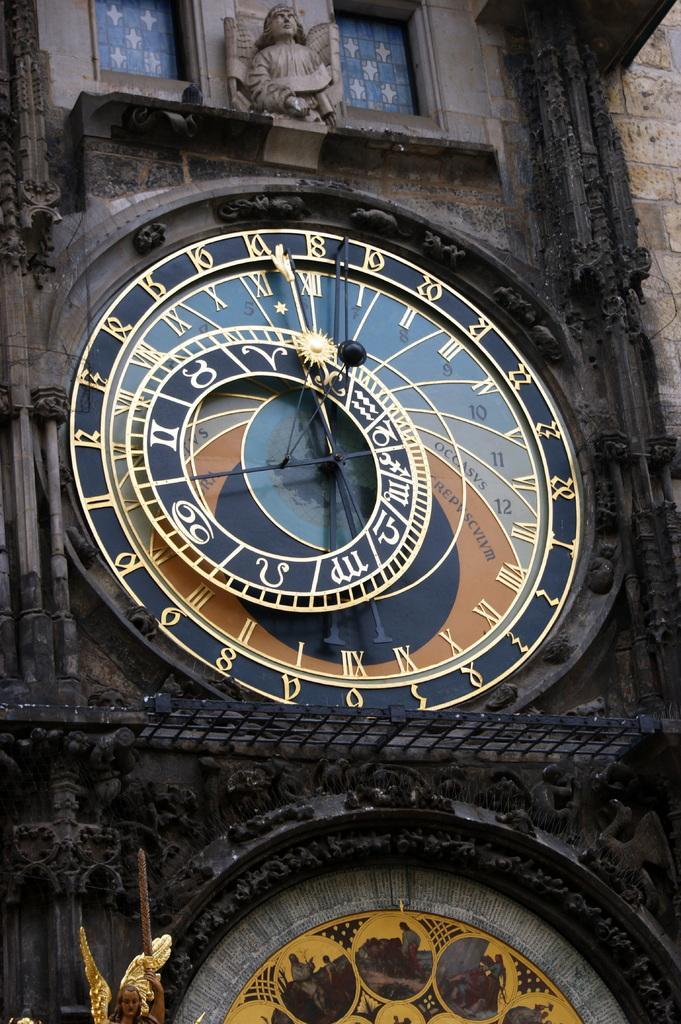Can you describe this image briefly? In this picture we can observe a clock on the wall of this building. There is a statue on this building. We can observe two windows on either sides of this statue. 